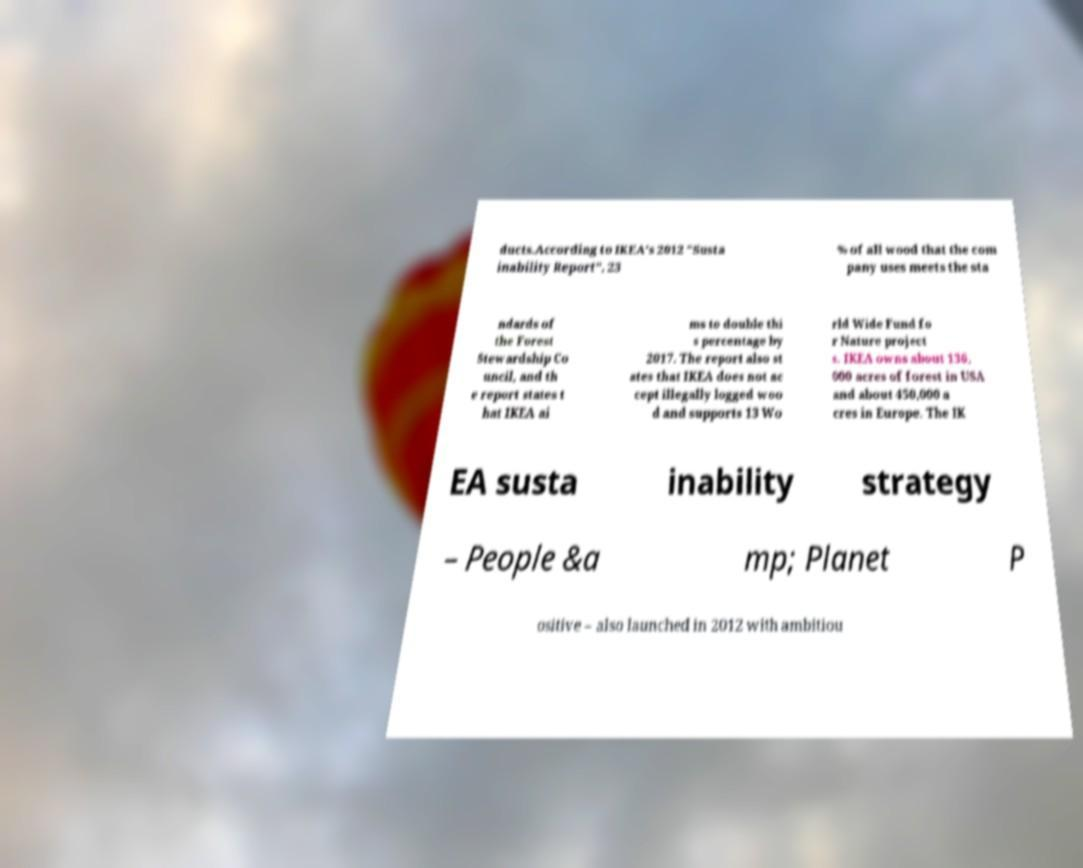For documentation purposes, I need the text within this image transcribed. Could you provide that? ducts.According to IKEA's 2012 "Susta inability Report", 23 % of all wood that the com pany uses meets the sta ndards of the Forest Stewardship Co uncil, and th e report states t hat IKEA ai ms to double thi s percentage by 2017. The report also st ates that IKEA does not ac cept illegally logged woo d and supports 13 Wo rld Wide Fund fo r Nature project s. IKEA owns about 136, 000 acres of forest in USA and about 450,000 a cres in Europe. The IK EA susta inability strategy – People &a mp; Planet P ositive – also launched in 2012 with ambitiou 